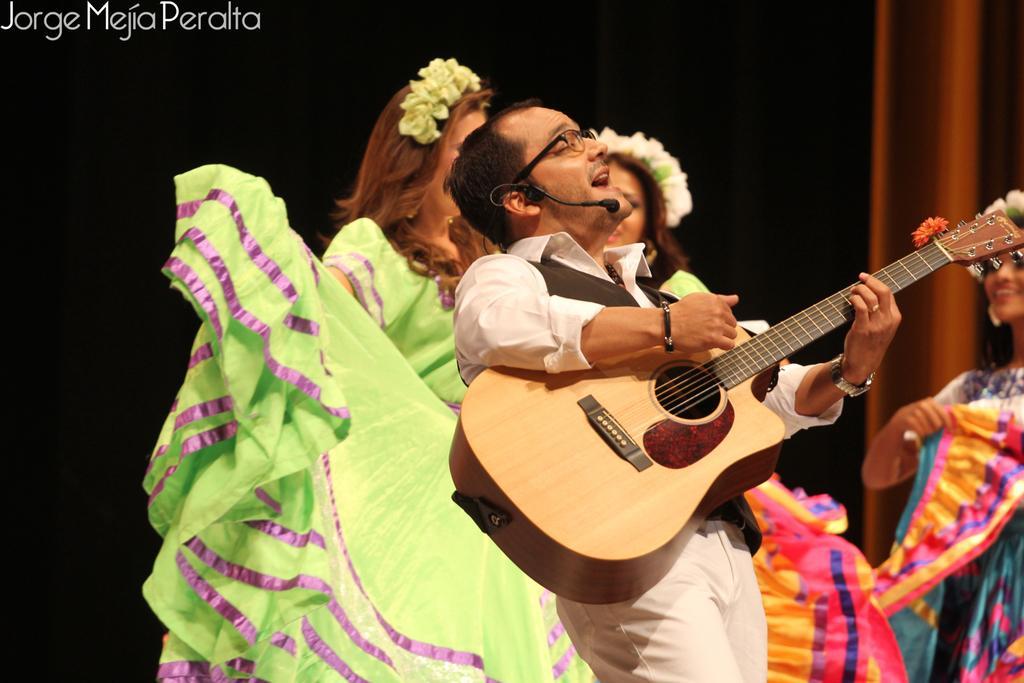Please provide a concise description of this image. There is a group of people standing on a stage. They are playing musical instruments. The backside of the woman is dancing. 